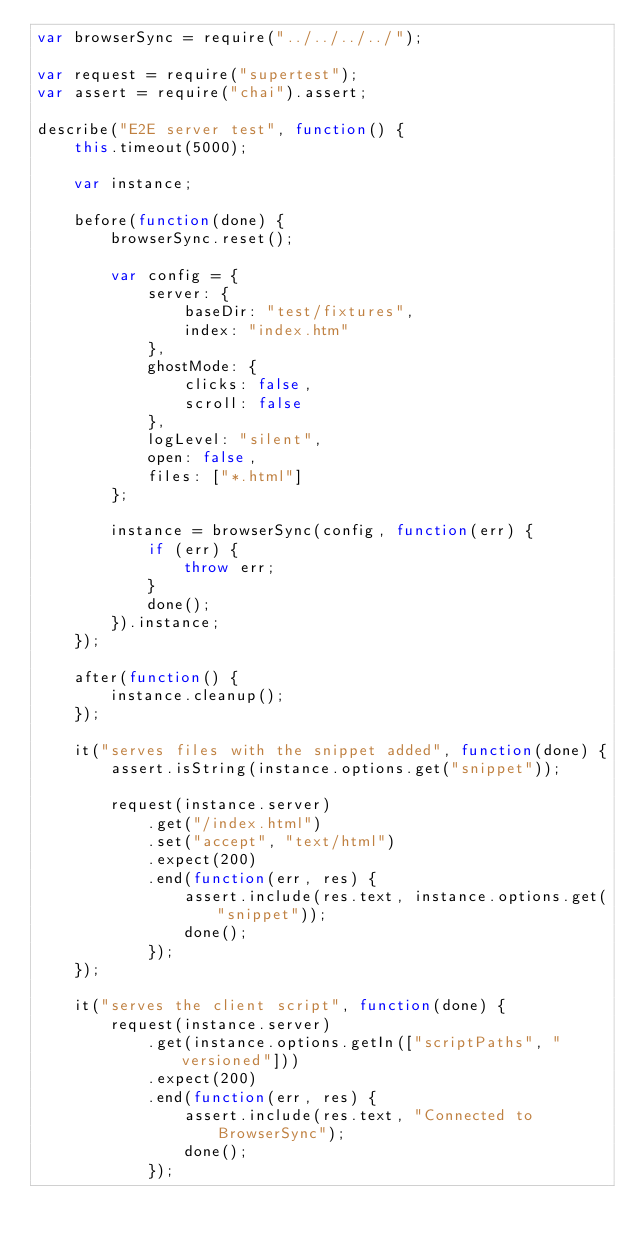<code> <loc_0><loc_0><loc_500><loc_500><_JavaScript_>var browserSync = require("../../../../");

var request = require("supertest");
var assert = require("chai").assert;

describe("E2E server test", function() {
    this.timeout(5000);

    var instance;

    before(function(done) {
        browserSync.reset();

        var config = {
            server: {
                baseDir: "test/fixtures",
                index: "index.htm"
            },
            ghostMode: {
                clicks: false,
                scroll: false
            },
            logLevel: "silent",
            open: false,
            files: ["*.html"]
        };

        instance = browserSync(config, function(err) {
            if (err) {
                throw err;
            }
            done();
        }).instance;
    });

    after(function() {
        instance.cleanup();
    });

    it("serves files with the snippet added", function(done) {
        assert.isString(instance.options.get("snippet"));

        request(instance.server)
            .get("/index.html")
            .set("accept", "text/html")
            .expect(200)
            .end(function(err, res) {
                assert.include(res.text, instance.options.get("snippet"));
                done();
            });
    });

    it("serves the client script", function(done) {
        request(instance.server)
            .get(instance.options.getIn(["scriptPaths", "versioned"]))
            .expect(200)
            .end(function(err, res) {
                assert.include(res.text, "Connected to BrowserSync");
                done();
            });</code> 